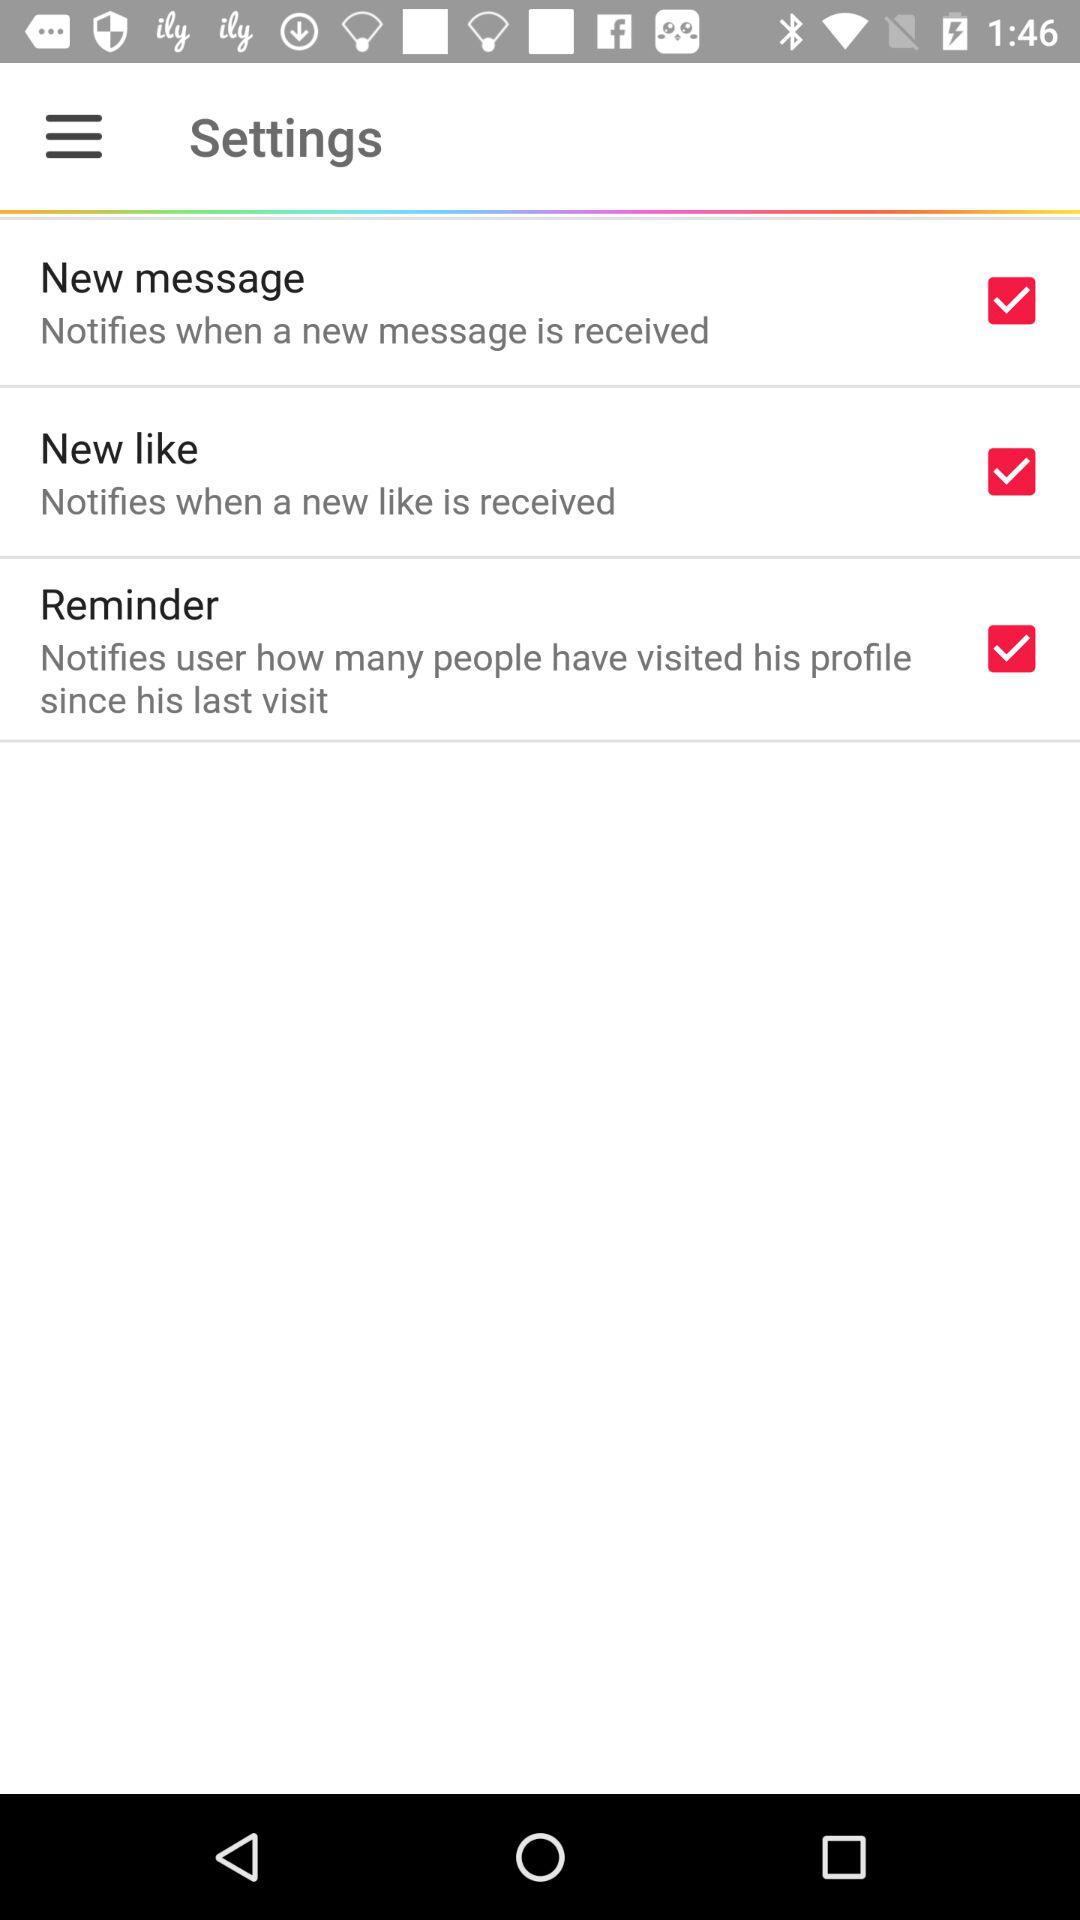How many new messages are there?
When the provided information is insufficient, respond with <no answer>. <no answer> 